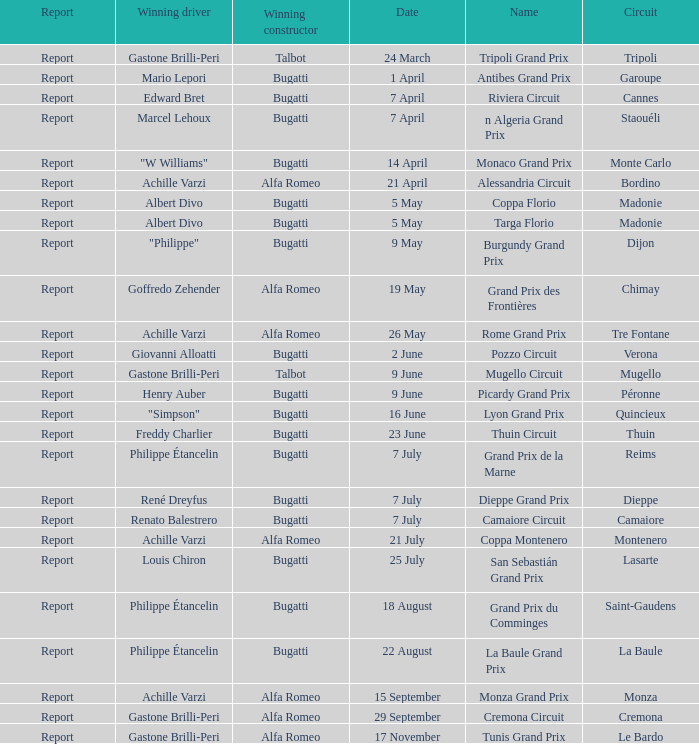What Circuit has a Winning constructor of bugatti, and a Winning driver of edward bret? Cannes. 